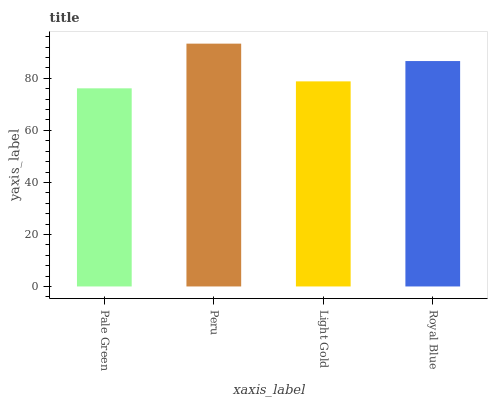Is Pale Green the minimum?
Answer yes or no. Yes. Is Peru the maximum?
Answer yes or no. Yes. Is Light Gold the minimum?
Answer yes or no. No. Is Light Gold the maximum?
Answer yes or no. No. Is Peru greater than Light Gold?
Answer yes or no. Yes. Is Light Gold less than Peru?
Answer yes or no. Yes. Is Light Gold greater than Peru?
Answer yes or no. No. Is Peru less than Light Gold?
Answer yes or no. No. Is Royal Blue the high median?
Answer yes or no. Yes. Is Light Gold the low median?
Answer yes or no. Yes. Is Pale Green the high median?
Answer yes or no. No. Is Royal Blue the low median?
Answer yes or no. No. 